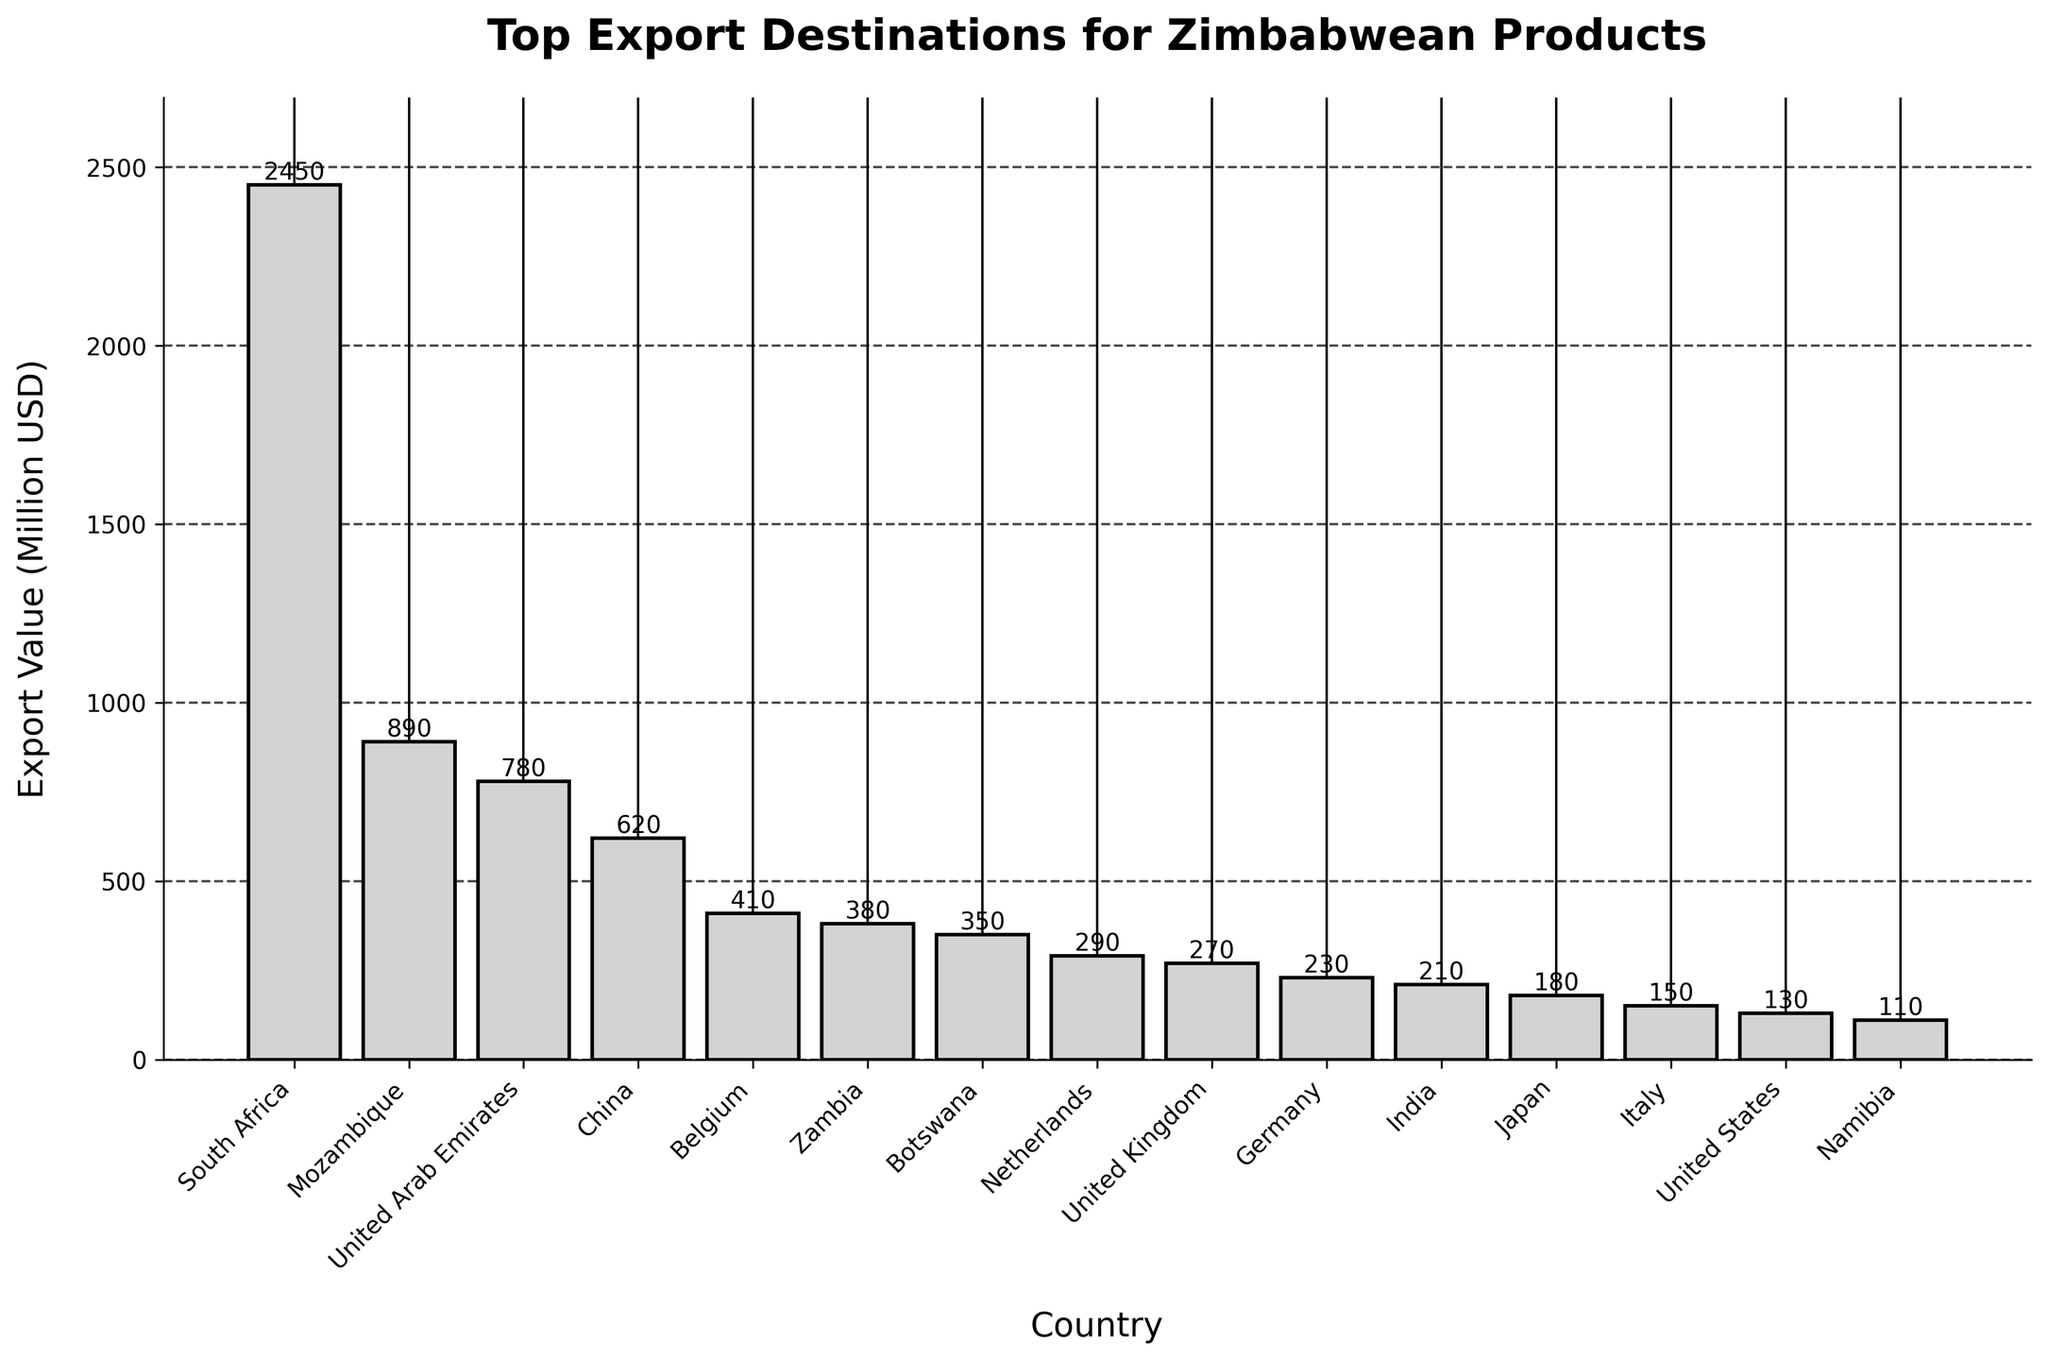Which country is the top export destination for Zimbabwean products? The bar representing South Africa is the tallest among all the bars, indicating it has the highest export value.
Answer: South Africa What is the total export value of the top three destinations? The export values are: South Africa (2450), Mozambique (890), and United Arab Emirates (780). Summing them: 2450 + 890 + 780 = 4120.
Answer: 4120 Which country has a higher export value, China or Belgium? Observing the heights of the bars: China’s bar is taller than Belgium’s, indicating a higher export value for China.
Answer: China What is the difference in export value between the United Kingdom and the United States? The export value for the United Kingdom is 270 and for the United States is 130. The difference is 270 - 130 = 140.
Answer: 140 Is the export value for Germany greater than that for India? The height of Germany’s bar is greater than that of India's, indicating a higher export value for Germany.
Answer: Yes, Germany What’s the approximate average export value of the top five destinations? The export values for the top five are: South Africa (2450), Mozambique (890), United Arab Emirates (780), China (620), and Belgium (410). Their sum is 2450 + 890 + 780 + 620 + 410 = 5150. The average is 5150 / 5 = 1030.
Answer: 1030 What is the combined export value of Botswana and Zambia? The export values are: Botswana (350) and Zambia (380). Summing them: 350 + 380 = 730.
Answer: 730 Among the European countries listed, which one has the highest export value? Observing the bars for European countries: Belgium, Netherlands, United Kingdom, Germany, Italy, Belgium has the tallest bar, indicating the highest export value.
Answer: Belgium Is Namibia's export value less than Japan's? Comparing the heights of the bars: Namibia’s bar is shorter than Japan’s, indicating a lower export value for Namibia.
Answer: Yes, Namibia What is the range of export values among the countries listed? The highest export value is South Africa (2450) and the lowest is Namibia (110). The range is 2450 - 110 = 2340.
Answer: 2340 